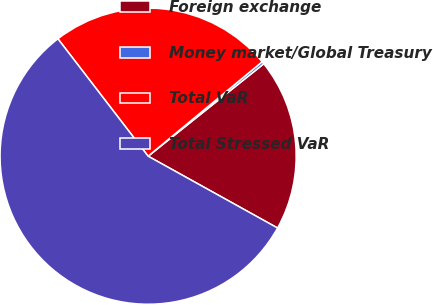Convert chart to OTSL. <chart><loc_0><loc_0><loc_500><loc_500><pie_chart><fcel>Foreign exchange<fcel>Money market/Global Treasury<fcel>Total VaR<fcel>Total Stressed VaR<nl><fcel>18.79%<fcel>0.28%<fcel>24.42%<fcel>56.51%<nl></chart> 